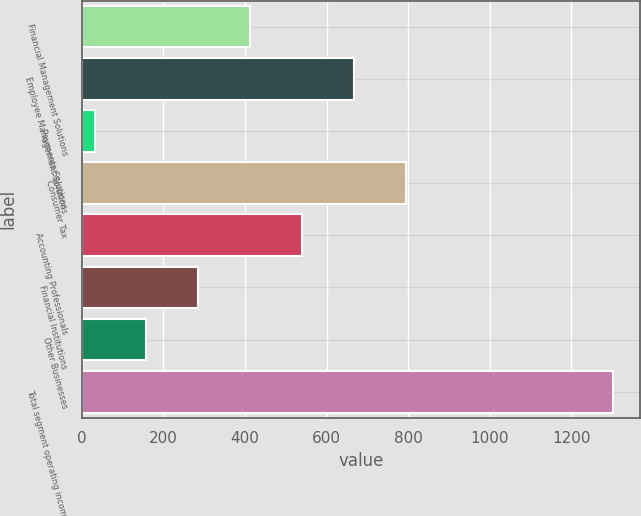<chart> <loc_0><loc_0><loc_500><loc_500><bar_chart><fcel>Financial Management Solutions<fcel>Employee Management Solutions<fcel>Payments Solutions<fcel>Consumer Tax<fcel>Accounting Professionals<fcel>Financial Institutions<fcel>Other Businesses<fcel>Total segment operating income<nl><fcel>412.78<fcel>666.9<fcel>31.6<fcel>793.96<fcel>539.84<fcel>285.72<fcel>158.66<fcel>1302.2<nl></chart> 